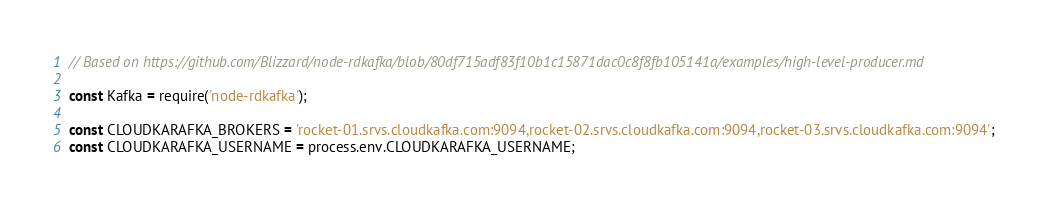<code> <loc_0><loc_0><loc_500><loc_500><_JavaScript_>// Based on https://github.com/Blizzard/node-rdkafka/blob/80df715adf83f10b1c15871dac0c8f8fb105141a/examples/high-level-producer.md

const Kafka = require('node-rdkafka');

const CLOUDKARAFKA_BROKERS = 'rocket-01.srvs.cloudkafka.com:9094,rocket-02.srvs.cloudkafka.com:9094,rocket-03.srvs.cloudkafka.com:9094';
const CLOUDKARAFKA_USERNAME = process.env.CLOUDKARAFKA_USERNAME;</code> 